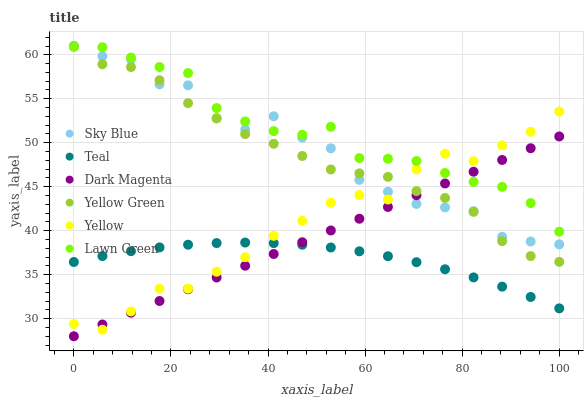Does Teal have the minimum area under the curve?
Answer yes or no. Yes. Does Lawn Green have the maximum area under the curve?
Answer yes or no. Yes. Does Dark Magenta have the minimum area under the curve?
Answer yes or no. No. Does Dark Magenta have the maximum area under the curve?
Answer yes or no. No. Is Dark Magenta the smoothest?
Answer yes or no. Yes. Is Sky Blue the roughest?
Answer yes or no. Yes. Is Yellow the smoothest?
Answer yes or no. No. Is Yellow the roughest?
Answer yes or no. No. Does Dark Magenta have the lowest value?
Answer yes or no. Yes. Does Yellow have the lowest value?
Answer yes or no. No. Does Yellow Green have the highest value?
Answer yes or no. Yes. Does Dark Magenta have the highest value?
Answer yes or no. No. Is Teal less than Yellow Green?
Answer yes or no. Yes. Is Lawn Green greater than Teal?
Answer yes or no. Yes. Does Dark Magenta intersect Sky Blue?
Answer yes or no. Yes. Is Dark Magenta less than Sky Blue?
Answer yes or no. No. Is Dark Magenta greater than Sky Blue?
Answer yes or no. No. Does Teal intersect Yellow Green?
Answer yes or no. No. 